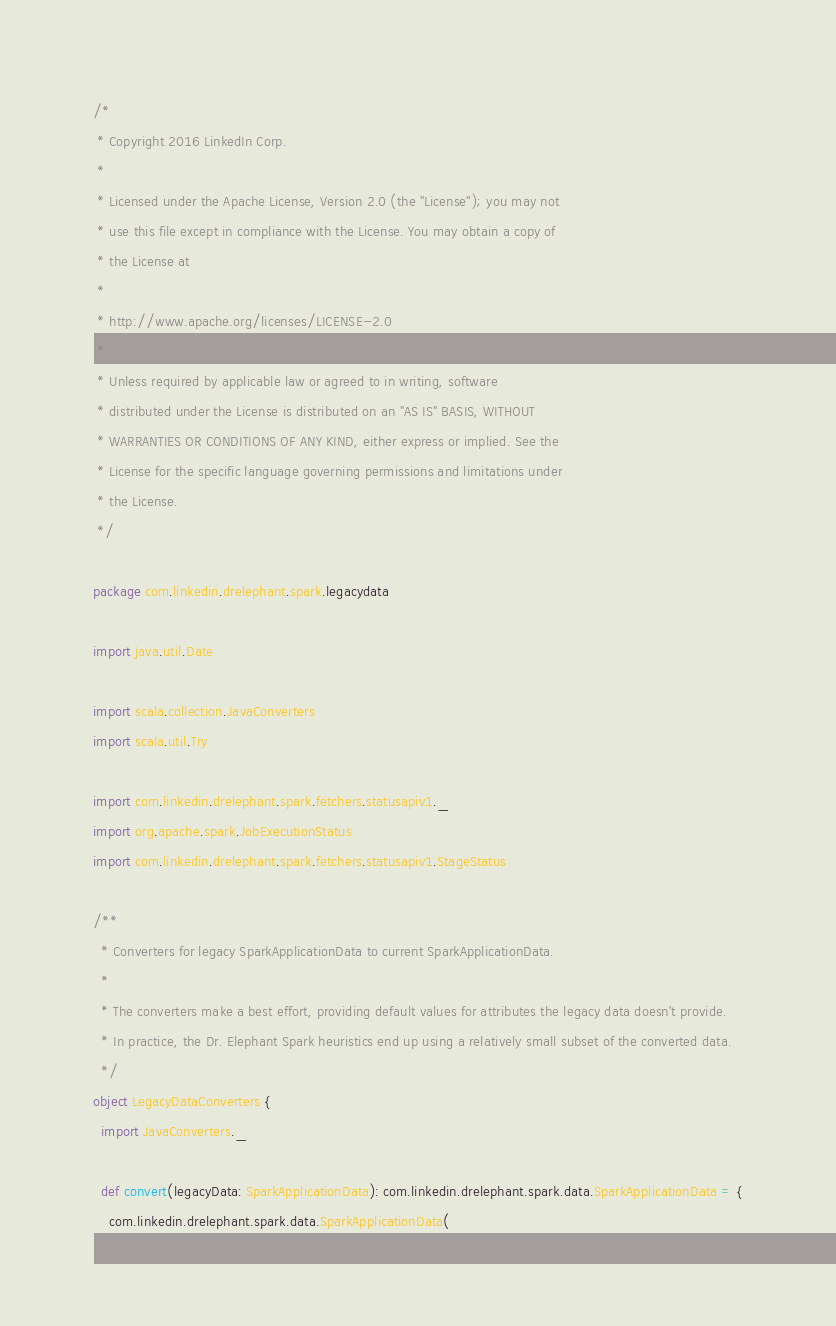<code> <loc_0><loc_0><loc_500><loc_500><_Scala_>/*
 * Copyright 2016 LinkedIn Corp.
 *
 * Licensed under the Apache License, Version 2.0 (the "License"); you may not
 * use this file except in compliance with the License. You may obtain a copy of
 * the License at
 *
 * http://www.apache.org/licenses/LICENSE-2.0
 *
 * Unless required by applicable law or agreed to in writing, software
 * distributed under the License is distributed on an "AS IS" BASIS, WITHOUT
 * WARRANTIES OR CONDITIONS OF ANY KIND, either express or implied. See the
 * License for the specific language governing permissions and limitations under
 * the License.
 */

package com.linkedin.drelephant.spark.legacydata

import java.util.Date

import scala.collection.JavaConverters
import scala.util.Try

import com.linkedin.drelephant.spark.fetchers.statusapiv1._
import org.apache.spark.JobExecutionStatus
import com.linkedin.drelephant.spark.fetchers.statusapiv1.StageStatus

/**
  * Converters for legacy SparkApplicationData to current SparkApplicationData.
  *
  * The converters make a best effort, providing default values for attributes the legacy data doesn't provide.
  * In practice, the Dr. Elephant Spark heuristics end up using a relatively small subset of the converted data.
  */
object LegacyDataConverters {
  import JavaConverters._

  def convert(legacyData: SparkApplicationData): com.linkedin.drelephant.spark.data.SparkApplicationData = {
    com.linkedin.drelephant.spark.data.SparkApplicationData(</code> 